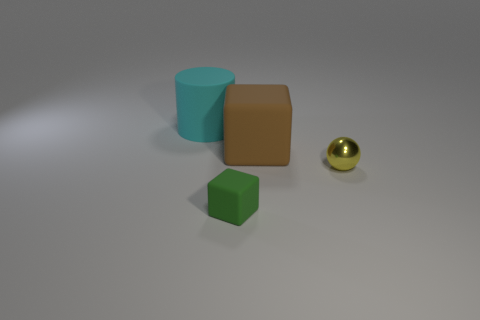Add 1 large green rubber balls. How many objects exist? 5 Subtract all brown cubes. How many cubes are left? 1 Subtract all cylinders. How many objects are left? 3 Add 2 spheres. How many spheres are left? 3 Add 3 big brown things. How many big brown things exist? 4 Subtract 0 red blocks. How many objects are left? 4 Subtract 2 cubes. How many cubes are left? 0 Subtract all red balls. Subtract all brown cylinders. How many balls are left? 1 Subtract all small brown blocks. Subtract all rubber cylinders. How many objects are left? 3 